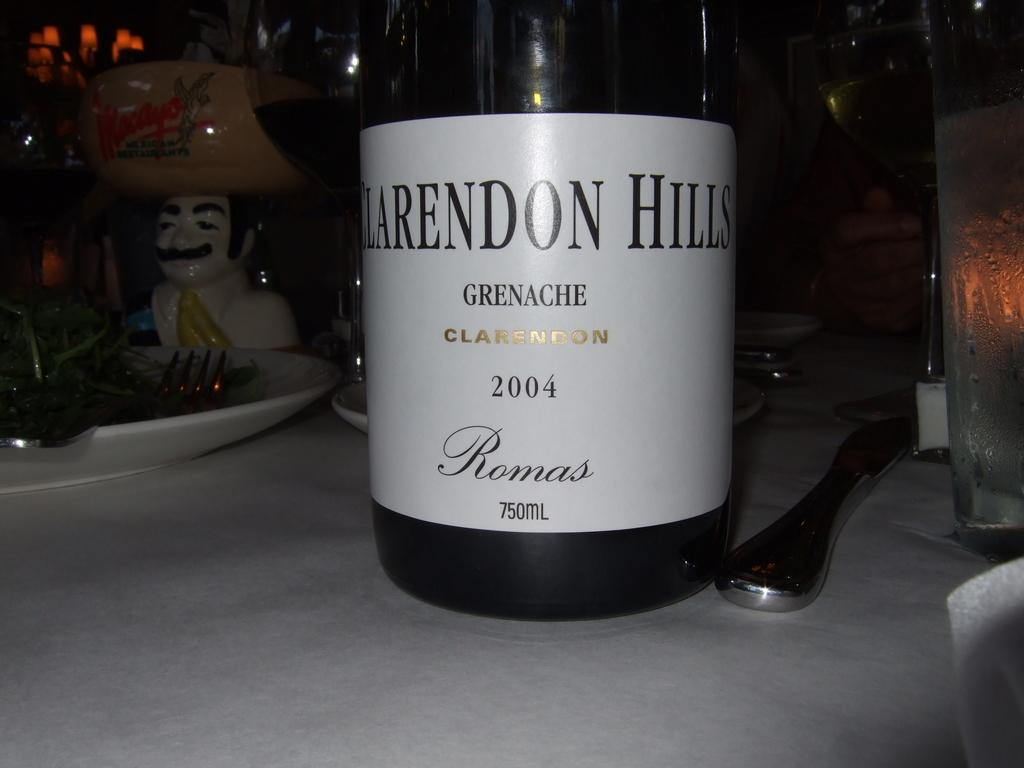<image>
Render a clear and concise summary of the photo. Clarendon Hills grenache clarendo wine that is from 2004 